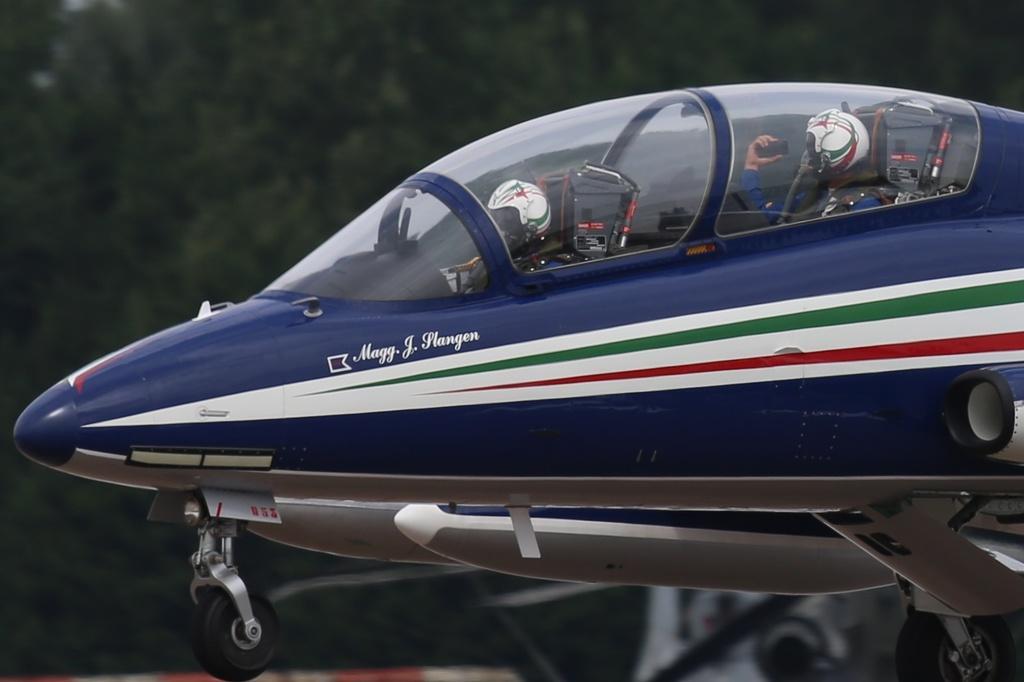Describe this image in one or two sentences. In the middle of this image, there are two persons sitting in a violet color aircraft. And the background is blurred. 